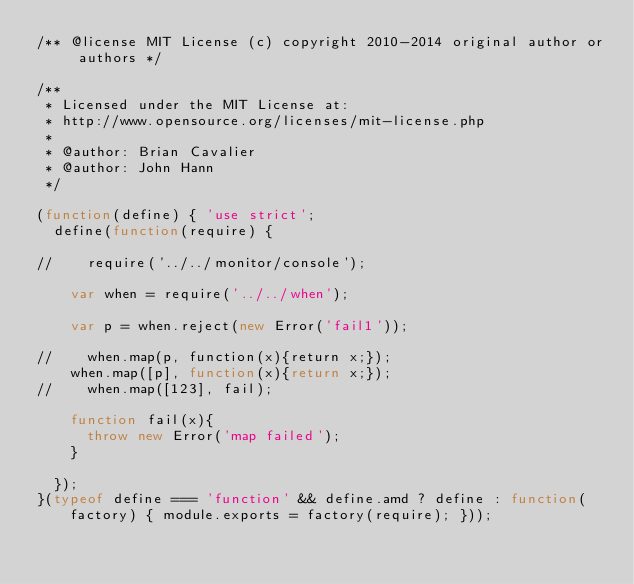<code> <loc_0><loc_0><loc_500><loc_500><_JavaScript_>/** @license MIT License (c) copyright 2010-2014 original author or authors */

/**
 * Licensed under the MIT License at:
 * http://www.opensource.org/licenses/mit-license.php
 *
 * @author: Brian Cavalier
 * @author: John Hann
 */

(function(define) { 'use strict';
	define(function(require) {

//		require('../../monitor/console');

		var when = require('../../when');

		var p = when.reject(new Error('fail1'));

//		when.map(p, function(x){return x;});
		when.map([p], function(x){return x;});
//		when.map([123], fail);

		function fail(x){
			throw new Error('map failed');
		}

	});
}(typeof define === 'function' && define.amd ? define : function(factory) { module.exports = factory(require); }));

</code> 